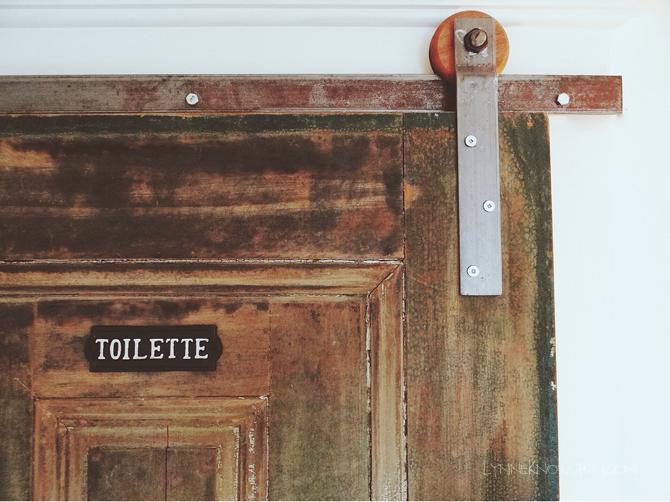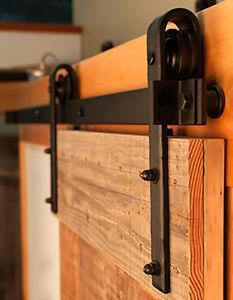The first image is the image on the left, the second image is the image on the right. Examine the images to the left and right. Is the description "The door section shown in the left image is not displayed at an angle." accurate? Answer yes or no. Yes. 